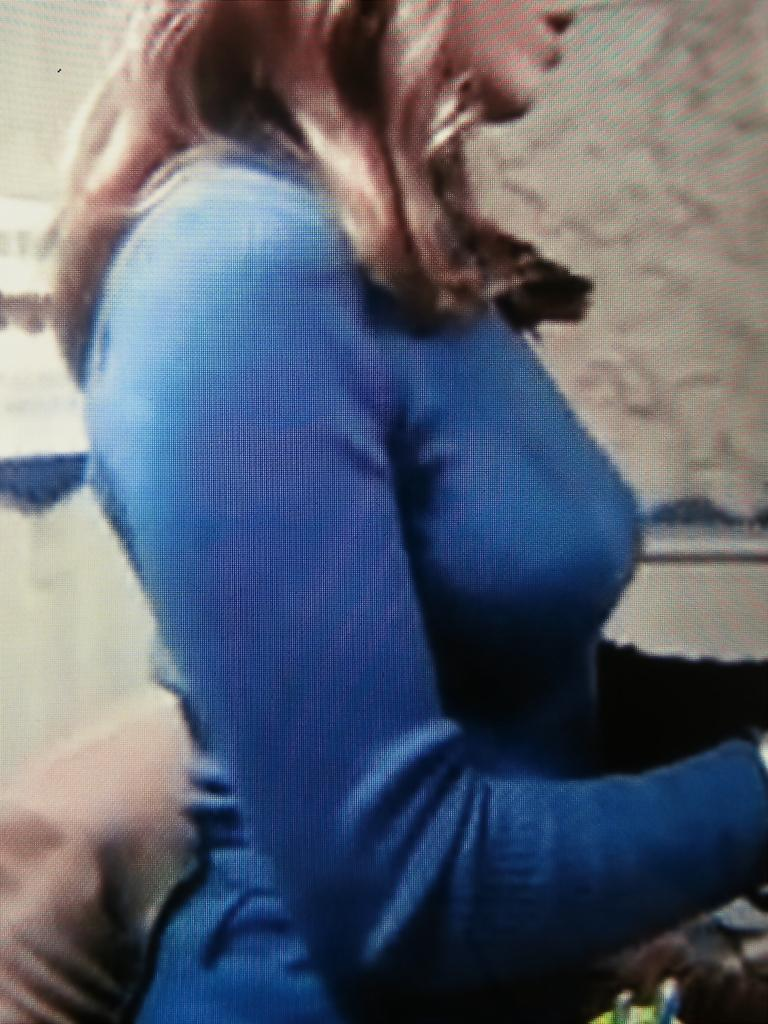Who is present in the image? There is a woman in the image. What is the woman doing in the image? The woman is standing. What is the woman wearing in the image? The woman is wearing a blue dress. What can be seen in the background of the image? There is a wall in the background of the image. What is on the wall in the background? There is a switch on the wall in the background. Can you see the ocean in the background of the image? No, there is no ocean visible in the image. The background features a wall with a switch. 